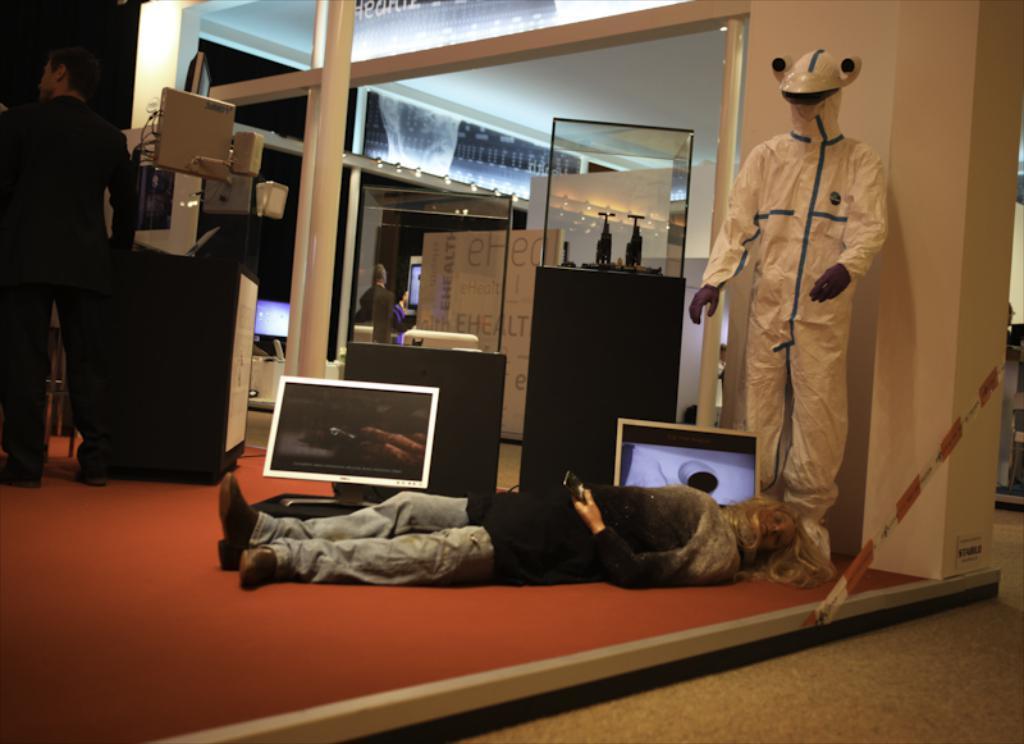Please provide a concise description of this image. In this image I can see the person is lying and I can also see few people at the back. In the background I can see few systems and few glass objects and the wall is in white color. 